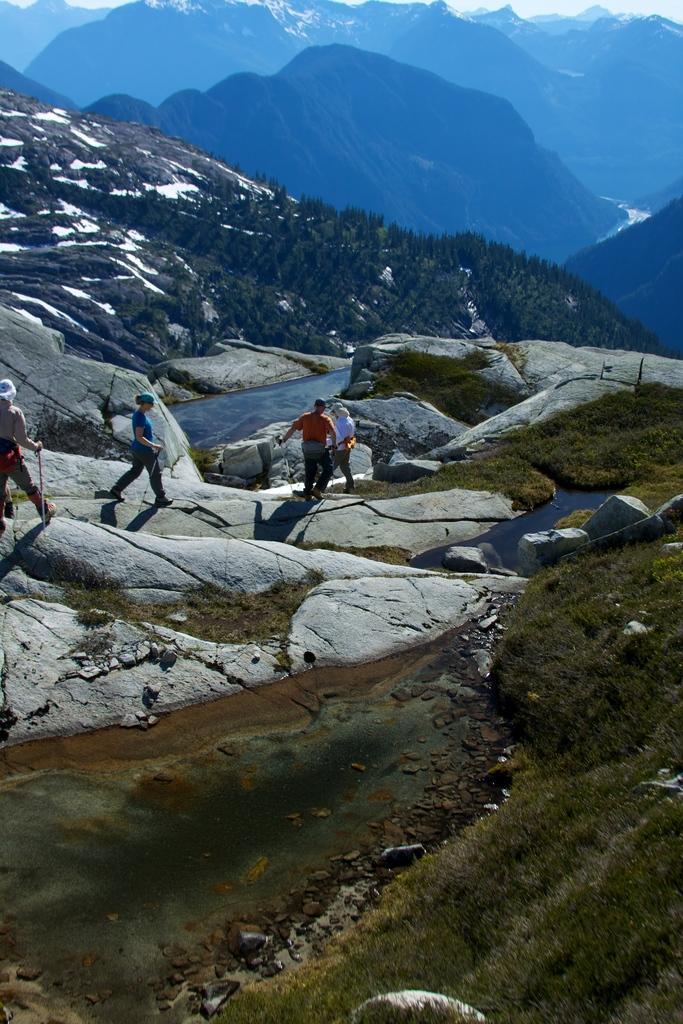Could you give a brief overview of what you see in this image? In this image we can see some people on the ground. One man and woman are holding sticks in their hands, we can also see the water and the grass. In the background, we can see a group of trees, hills and the sky. 